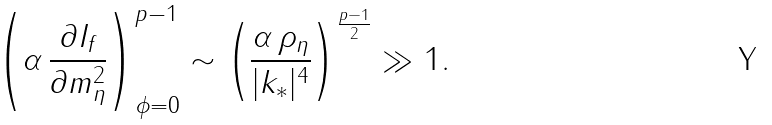Convert formula to latex. <formula><loc_0><loc_0><loc_500><loc_500>\left ( \alpha \, \frac { \partial I _ { f } } { \partial m ^ { 2 } _ { \eta } } \right ) _ { \phi = 0 } ^ { p - 1 } \sim \left ( \frac { \alpha \, \rho _ { \eta } } { | { k } _ { * } | ^ { 4 } } \right ) ^ { \frac { p - 1 } { 2 } } \gg 1 .</formula> 